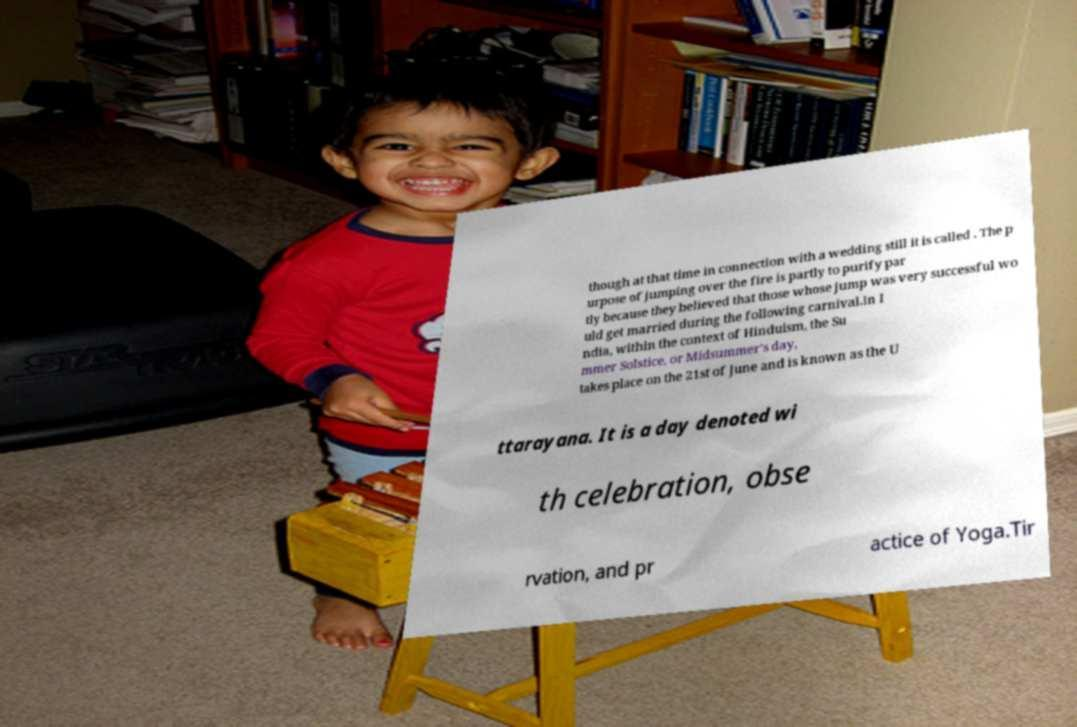Please identify and transcribe the text found in this image. though at that time in connection with a wedding still it is called . The p urpose of jumping over the fire is partly to purify par tly because they believed that those whose jump was very successful wo uld get married during the following carnival.In I ndia, within the context of Hinduism, the Su mmer Solstice, or Midsummer's day, takes place on the 21st of June and is known as the U ttarayana. It is a day denoted wi th celebration, obse rvation, and pr actice of Yoga.Tir 